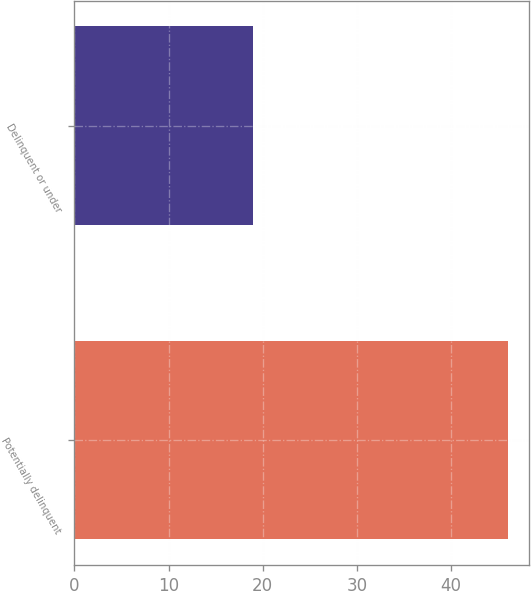Convert chart. <chart><loc_0><loc_0><loc_500><loc_500><bar_chart><fcel>Potentially delinquent<fcel>Delinquent or under<nl><fcel>46<fcel>19<nl></chart> 